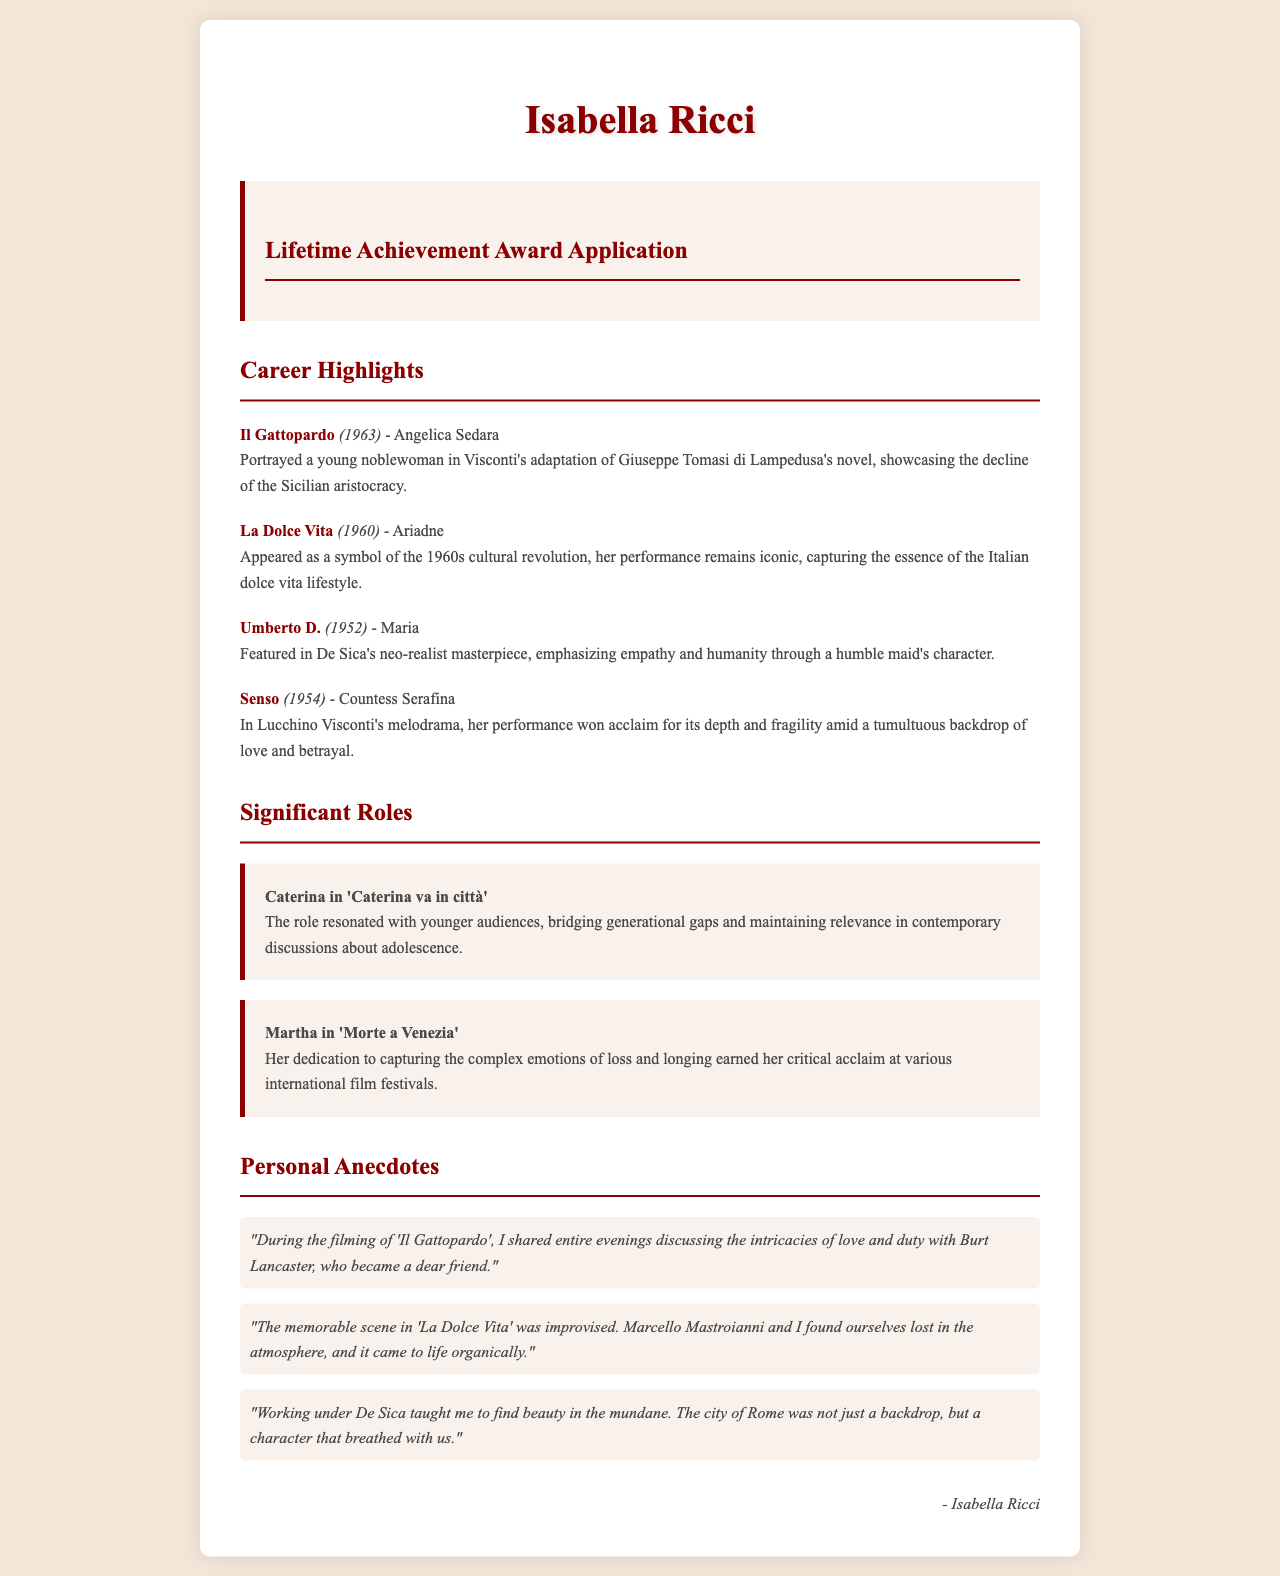what role did Isabella Ricci play in 'Il Gattopardo'? The document specifies that Isabella Ricci played the role of Angelica Sedara in 'Il Gattopardo'.
Answer: Angelica Sedara in what year was 'La Dolce Vita' released? The document states that 'La Dolce Vita' was released in 1960.
Answer: 1960 what is a significant role mentioned in the application? The document lists Caterina in 'Caterina va in città' as a significant role.
Answer: Caterina in 'Caterina va in città' who was a dear friend during the filming of 'Il Gattopardo'? The document mentions Burt Lancaster as a dear friend during the filming of 'Il Gattopardo'.
Answer: Burt Lancaster which director does Isabella Ricci credit with teaching her to find beauty in the mundane? The application states that De Sica taught her to find beauty in the mundane.
Answer: De Sica 